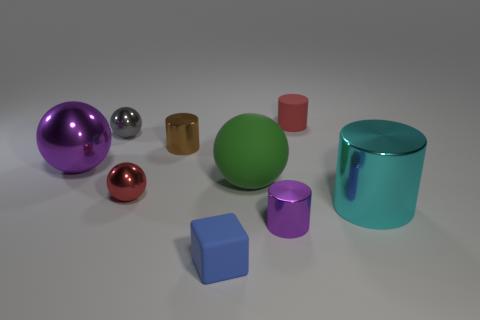What material is the object that is the same color as the matte cylinder?
Provide a short and direct response. Metal. The small cylinder that is made of the same material as the green thing is what color?
Offer a terse response. Red. There is a big metal thing left of the rubber cylinder; is it the same color as the tiny cylinder in front of the large metal cylinder?
Keep it short and to the point. Yes. Are there more purple metal objects that are in front of the big cyan shiny thing than shiny things that are left of the blue object?
Your answer should be compact. No. The large object that is the same shape as the tiny purple object is what color?
Your answer should be very brief. Cyan. Is there anything else that is the same shape as the blue rubber thing?
Your response must be concise. No. Does the large purple thing have the same shape as the big cyan metallic object that is to the right of the big purple sphere?
Offer a very short reply. No. What number of other objects are the same material as the blue thing?
Your answer should be very brief. 2. Do the large cylinder and the small cylinder that is in front of the big cyan cylinder have the same color?
Offer a terse response. No. There is a small cylinder that is in front of the cyan thing; what is it made of?
Keep it short and to the point. Metal. 